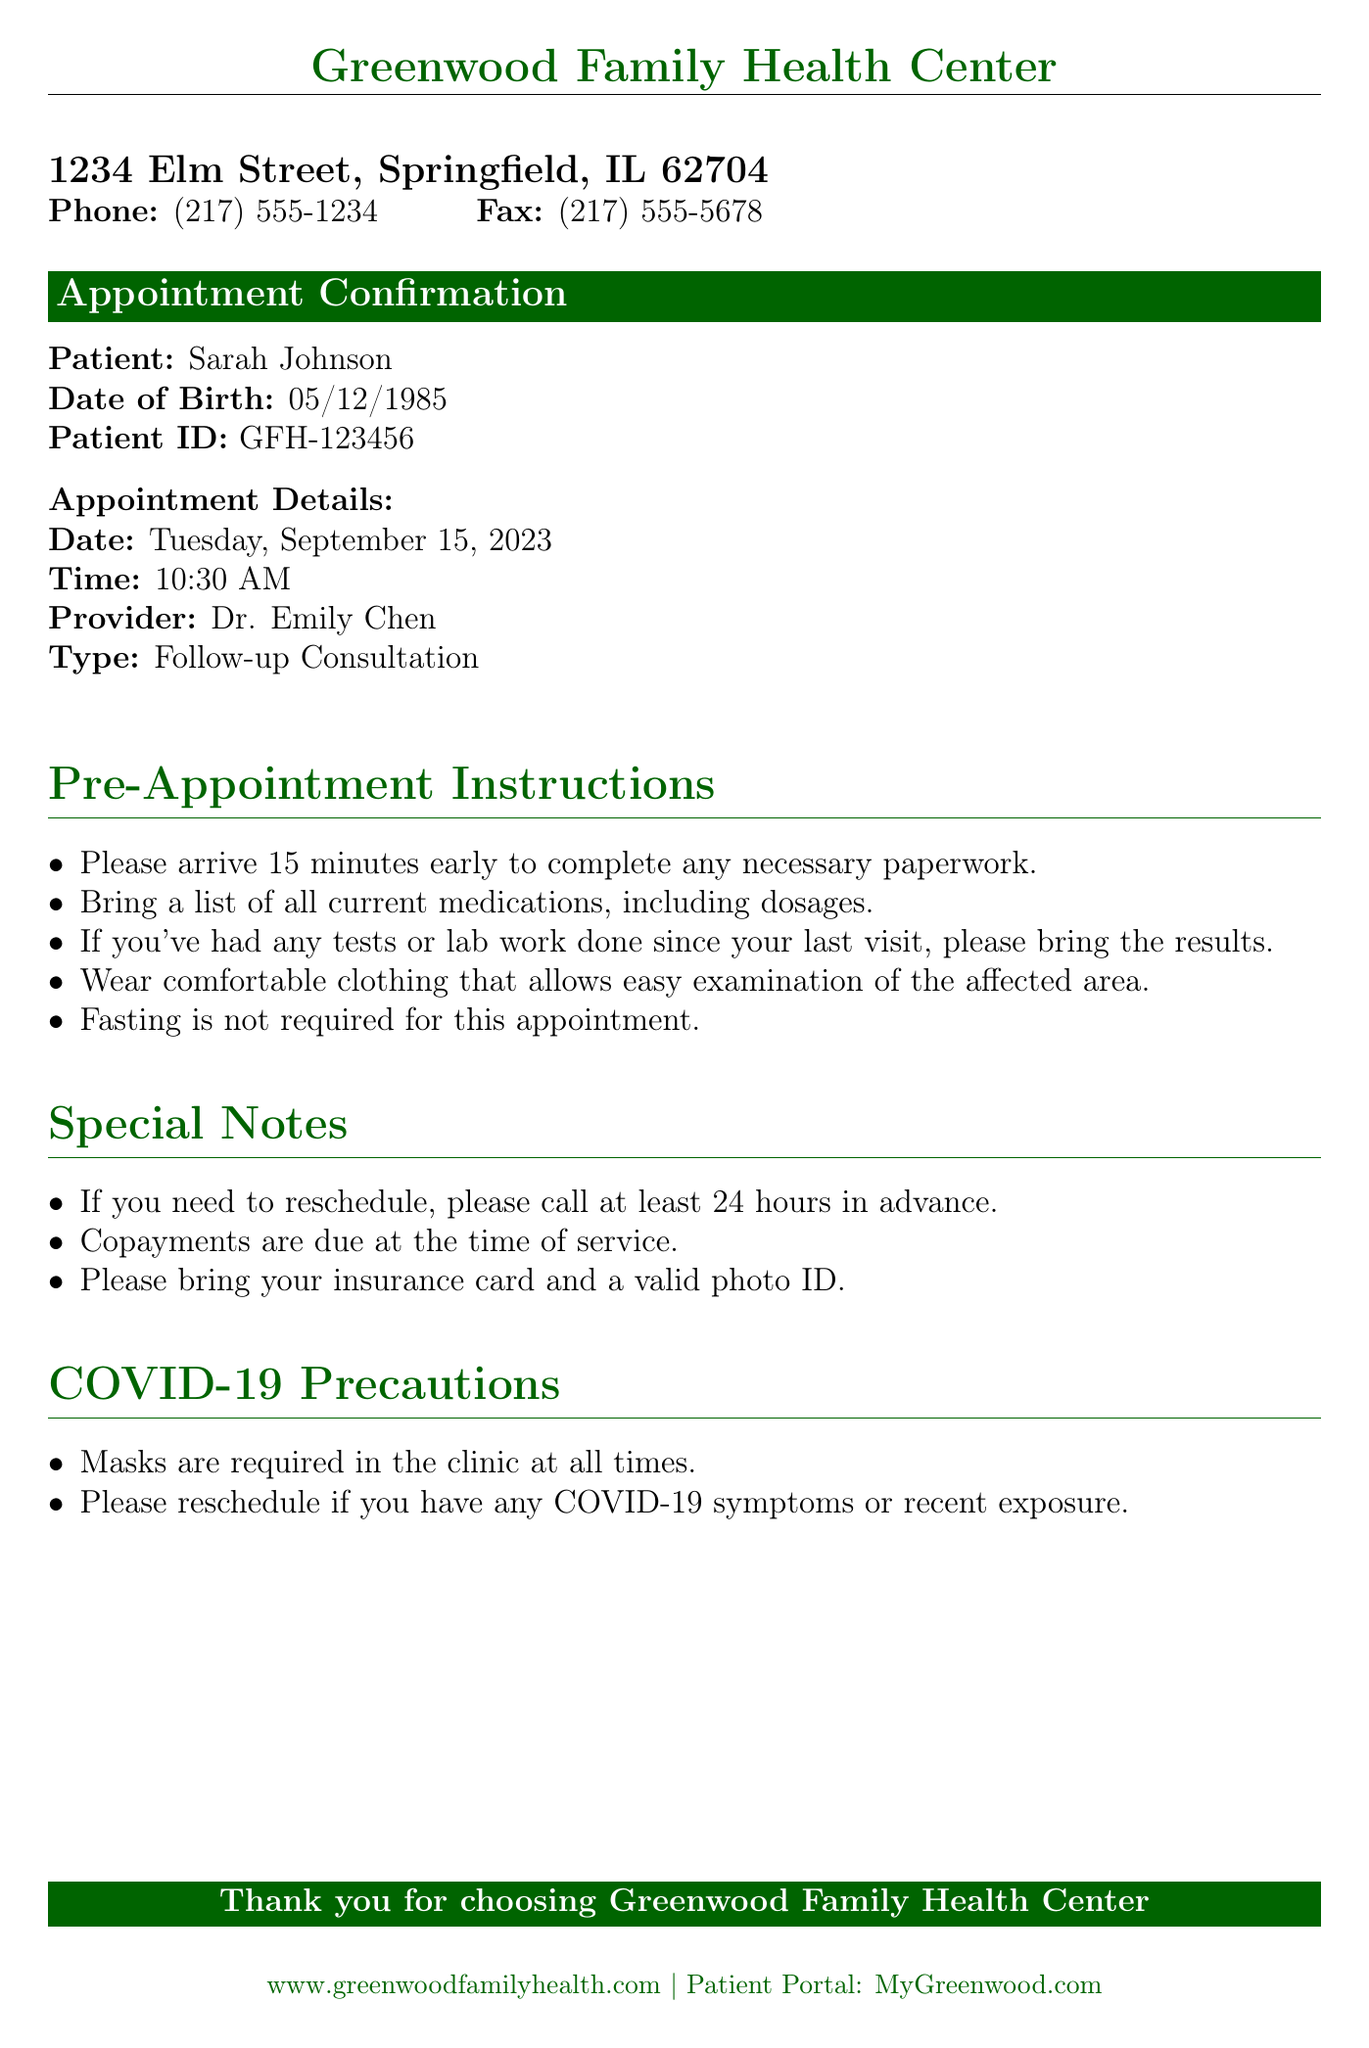What is the patient's name? The patient's name is specified at the beginning of the document under Patient details.
Answer: Sarah Johnson What is the appointment date? The appointment date is noted under Appointment Details in the document.
Answer: Tuesday, September 15, 2023 Who is the healthcare provider? The healthcare provider's name is listed along with the appointment details.
Answer: Dr. Emily Chen What items should the patient bring? The pre-appointment instructions detail what the patient needs to bring for the consultation.
Answer: A list of all current medications What time should the patient arrive? The document specifies how early the patient should arrive under Pre-Appointment Instructions.
Answer: 15 minutes early Is fasting required for this appointment? The pre-appointment instructions indicate dietary requirements for the appointment.
Answer: No What to do if needing to reschedule? The special notes section gives guidelines for rescheduling appointments.
Answer: Call at least 24 hours in advance What precautions are mentioned for COVID-19? The COVID-19 precautions section outlines the safety measures in place.
Answer: Masks are required in the clinic at all times What is the address of the clinic? The clinic's address is provided at the top of the document.
Answer: 1234 Elm Street, Springfield, IL 62704 